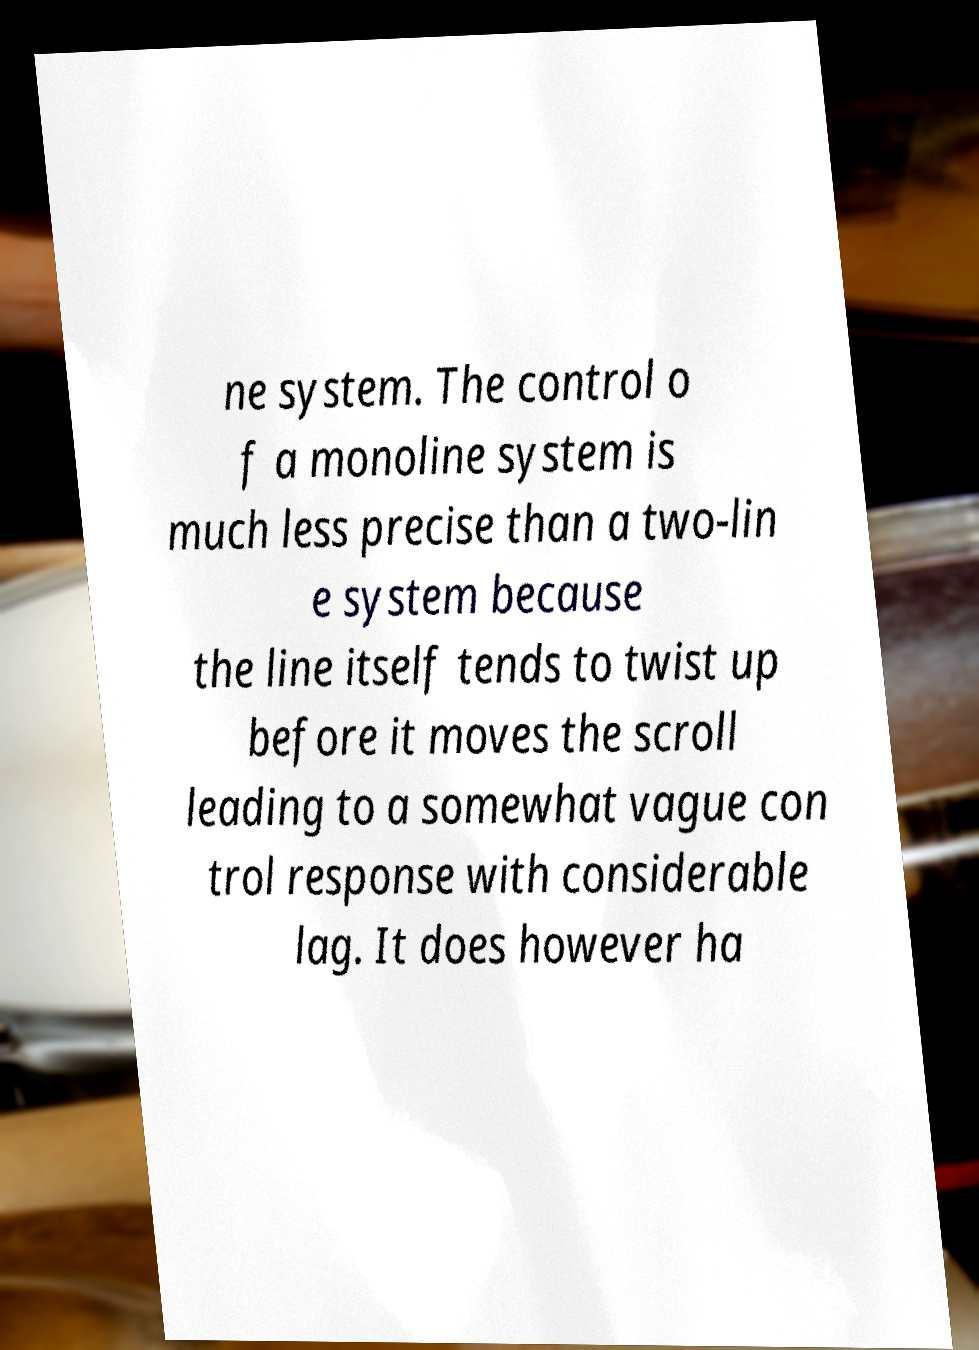Please read and relay the text visible in this image. What does it say? ne system. The control o f a monoline system is much less precise than a two-lin e system because the line itself tends to twist up before it moves the scroll leading to a somewhat vague con trol response with considerable lag. It does however ha 